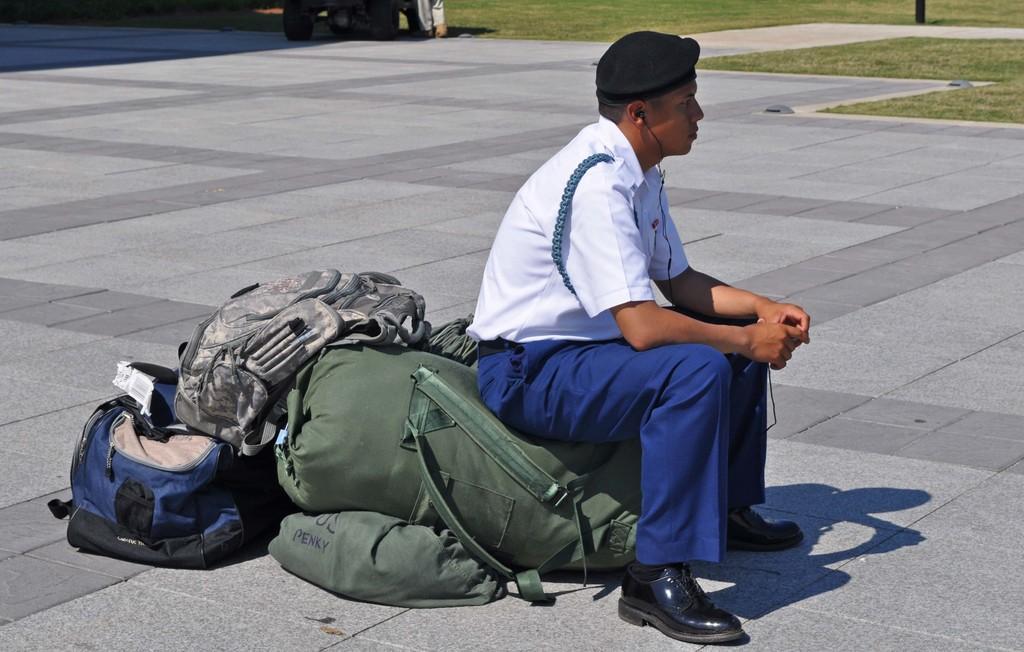Could you give a brief overview of what you see in this image? Person sitting on the bag ,grass is present in the right side. 